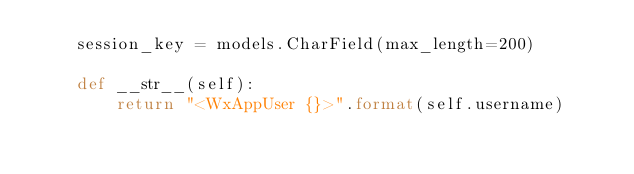<code> <loc_0><loc_0><loc_500><loc_500><_Python_>    session_key = models.CharField(max_length=200)

    def __str__(self):
        return "<WxAppUser {}>".format(self.username)</code> 